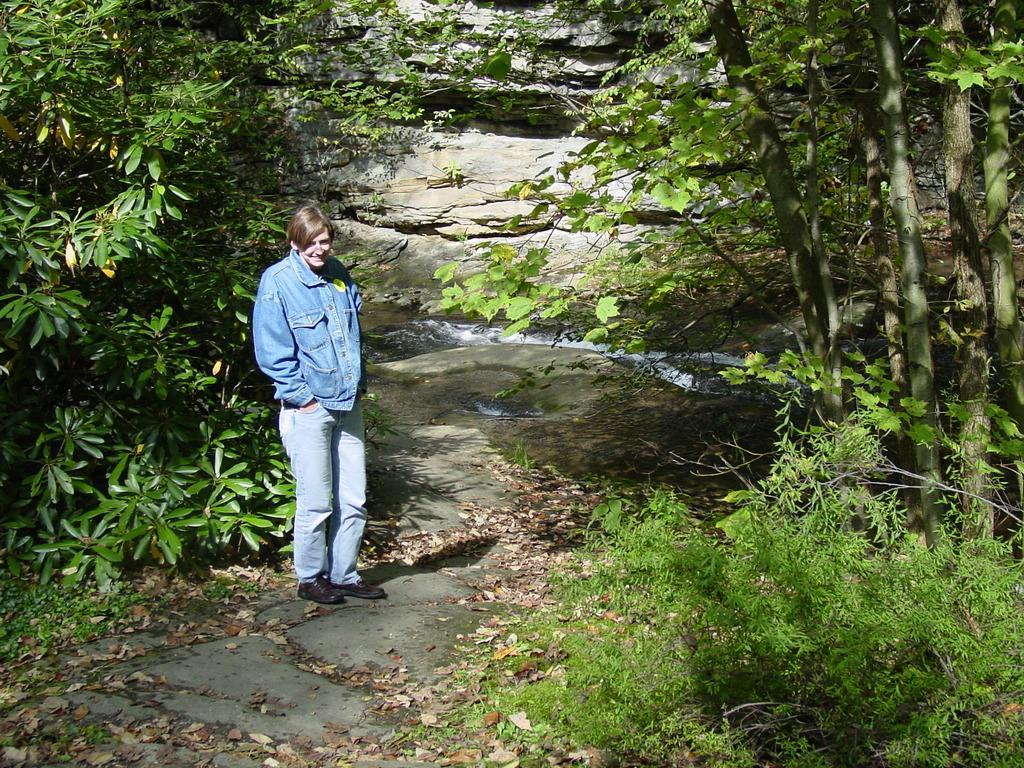How would you summarize this image in a sentence or two? In this image I can see a woman is standing and I can see she is wearing blue colour dress and black shoes. On the both side of this image I can see number of trees and in the background I can see water. 